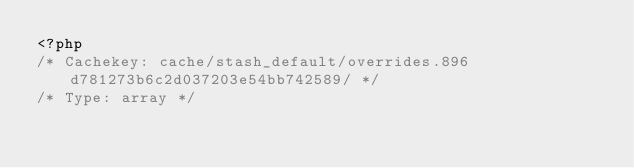<code> <loc_0><loc_0><loc_500><loc_500><_PHP_><?php 
/* Cachekey: cache/stash_default/overrides.896d781273b6c2d037203e54bb742589/ */
/* Type: array */</code> 